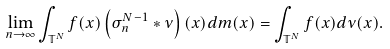<formula> <loc_0><loc_0><loc_500><loc_500>\lim _ { n \rightarrow \infty } \int _ { \mathbb { T } ^ { N } } f ( x ) \left ( \sigma _ { n } ^ { N - 1 } \ast \nu \right ) ( x ) d m ( x ) = \int _ { \mathbb { T } ^ { N } } f ( x ) d \nu ( x ) .</formula> 